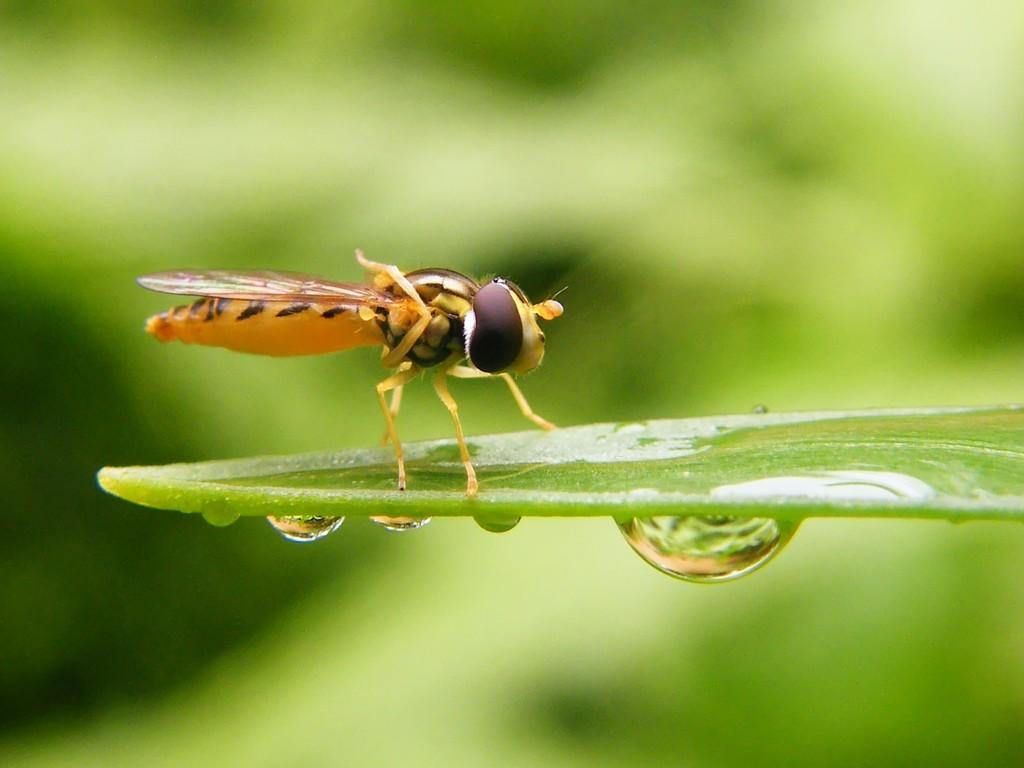What type of plant material is present in the image? There is a green leaf in the image. What is the condition of the leaf in the image? There are water droplets on the leaf. Is there any other living organism present on the leaf? Yes, there is an insect on the leaf. How would you describe the background of the image? The background of the image is blurred. What type of scarf is the insect wearing in the image? There is no scarf present in the image, and insects do not wear clothing. 